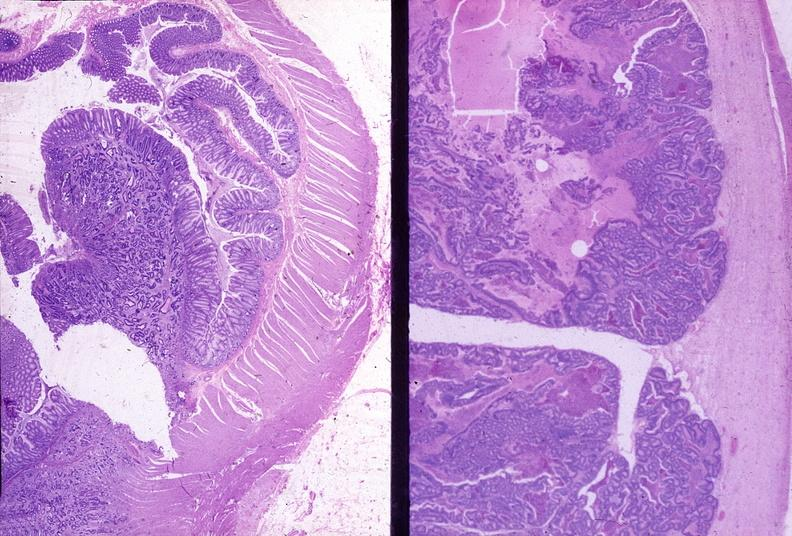s endometritis postpartum present?
Answer the question using a single word or phrase. No 